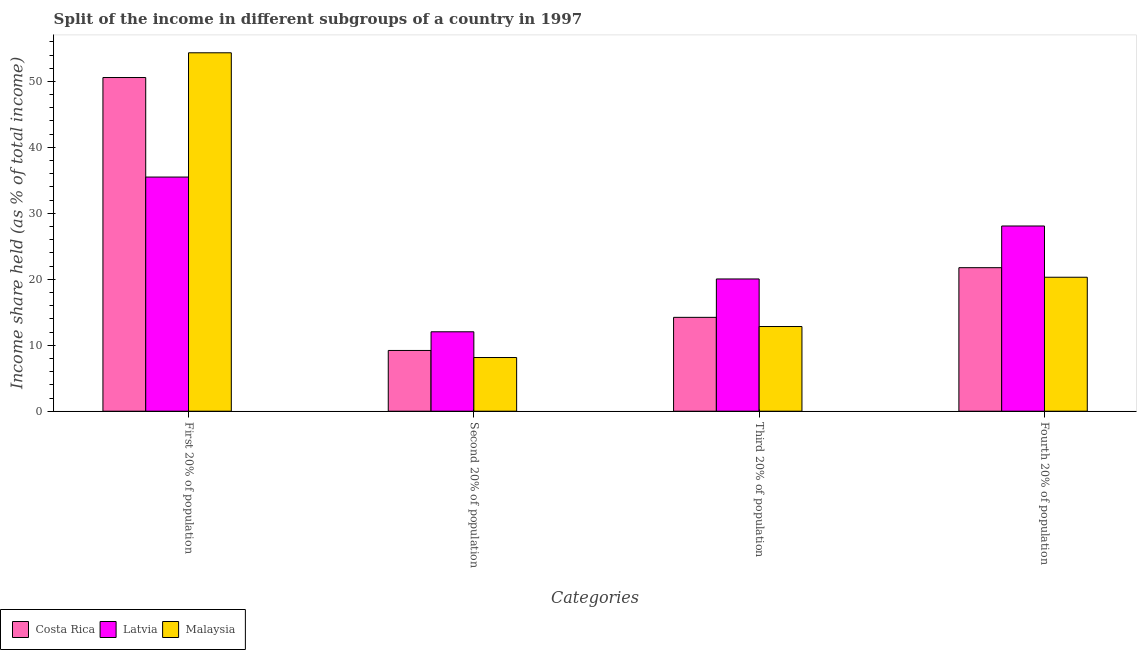How many groups of bars are there?
Make the answer very short. 4. Are the number of bars per tick equal to the number of legend labels?
Your answer should be compact. Yes. Are the number of bars on each tick of the X-axis equal?
Make the answer very short. Yes. How many bars are there on the 3rd tick from the left?
Provide a succinct answer. 3. What is the label of the 1st group of bars from the left?
Provide a short and direct response. First 20% of population. What is the share of the income held by fourth 20% of the population in Malaysia?
Give a very brief answer. 20.31. Across all countries, what is the maximum share of the income held by fourth 20% of the population?
Your response must be concise. 28.08. Across all countries, what is the minimum share of the income held by fourth 20% of the population?
Ensure brevity in your answer.  20.31. In which country was the share of the income held by third 20% of the population maximum?
Give a very brief answer. Latvia. In which country was the share of the income held by first 20% of the population minimum?
Provide a short and direct response. Latvia. What is the total share of the income held by third 20% of the population in the graph?
Give a very brief answer. 47.12. What is the difference between the share of the income held by third 20% of the population in Latvia and that in Malaysia?
Offer a terse response. 7.21. What is the difference between the share of the income held by second 20% of the population in Malaysia and the share of the income held by first 20% of the population in Latvia?
Make the answer very short. -27.36. What is the average share of the income held by first 20% of the population per country?
Give a very brief answer. 46.81. What is the difference between the share of the income held by second 20% of the population and share of the income held by first 20% of the population in Malaysia?
Offer a very short reply. -46.2. What is the ratio of the share of the income held by third 20% of the population in Costa Rica to that in Latvia?
Make the answer very short. 0.71. What is the difference between the highest and the second highest share of the income held by second 20% of the population?
Make the answer very short. 2.83. What is the difference between the highest and the lowest share of the income held by fourth 20% of the population?
Your answer should be very brief. 7.77. In how many countries, is the share of the income held by third 20% of the population greater than the average share of the income held by third 20% of the population taken over all countries?
Provide a succinct answer. 1. Is it the case that in every country, the sum of the share of the income held by fourth 20% of the population and share of the income held by third 20% of the population is greater than the sum of share of the income held by second 20% of the population and share of the income held by first 20% of the population?
Your answer should be very brief. No. What does the 3rd bar from the left in Fourth 20% of population represents?
Provide a short and direct response. Malaysia. What does the 3rd bar from the right in Fourth 20% of population represents?
Your answer should be very brief. Costa Rica. Is it the case that in every country, the sum of the share of the income held by first 20% of the population and share of the income held by second 20% of the population is greater than the share of the income held by third 20% of the population?
Ensure brevity in your answer.  Yes. How many countries are there in the graph?
Make the answer very short. 3. Does the graph contain any zero values?
Your answer should be very brief. No. Does the graph contain grids?
Keep it short and to the point. No. How are the legend labels stacked?
Give a very brief answer. Horizontal. What is the title of the graph?
Provide a short and direct response. Split of the income in different subgroups of a country in 1997. Does "Gabon" appear as one of the legend labels in the graph?
Offer a very short reply. No. What is the label or title of the X-axis?
Your response must be concise. Categories. What is the label or title of the Y-axis?
Keep it short and to the point. Income share held (as % of total income). What is the Income share held (as % of total income) of Costa Rica in First 20% of population?
Provide a succinct answer. 50.59. What is the Income share held (as % of total income) of Latvia in First 20% of population?
Your response must be concise. 35.5. What is the Income share held (as % of total income) in Malaysia in First 20% of population?
Provide a short and direct response. 54.34. What is the Income share held (as % of total income) of Costa Rica in Second 20% of population?
Your response must be concise. 9.21. What is the Income share held (as % of total income) of Latvia in Second 20% of population?
Your answer should be very brief. 12.04. What is the Income share held (as % of total income) in Malaysia in Second 20% of population?
Your response must be concise. 8.14. What is the Income share held (as % of total income) of Costa Rica in Third 20% of population?
Your answer should be compact. 14.23. What is the Income share held (as % of total income) of Latvia in Third 20% of population?
Make the answer very short. 20.05. What is the Income share held (as % of total income) of Malaysia in Third 20% of population?
Ensure brevity in your answer.  12.84. What is the Income share held (as % of total income) in Costa Rica in Fourth 20% of population?
Your response must be concise. 21.76. What is the Income share held (as % of total income) of Latvia in Fourth 20% of population?
Your response must be concise. 28.08. What is the Income share held (as % of total income) of Malaysia in Fourth 20% of population?
Your answer should be compact. 20.31. Across all Categories, what is the maximum Income share held (as % of total income) of Costa Rica?
Offer a very short reply. 50.59. Across all Categories, what is the maximum Income share held (as % of total income) of Latvia?
Provide a short and direct response. 35.5. Across all Categories, what is the maximum Income share held (as % of total income) of Malaysia?
Your response must be concise. 54.34. Across all Categories, what is the minimum Income share held (as % of total income) in Costa Rica?
Provide a short and direct response. 9.21. Across all Categories, what is the minimum Income share held (as % of total income) in Latvia?
Ensure brevity in your answer.  12.04. Across all Categories, what is the minimum Income share held (as % of total income) in Malaysia?
Provide a short and direct response. 8.14. What is the total Income share held (as % of total income) in Costa Rica in the graph?
Your answer should be very brief. 95.79. What is the total Income share held (as % of total income) in Latvia in the graph?
Ensure brevity in your answer.  95.67. What is the total Income share held (as % of total income) in Malaysia in the graph?
Make the answer very short. 95.63. What is the difference between the Income share held (as % of total income) in Costa Rica in First 20% of population and that in Second 20% of population?
Ensure brevity in your answer.  41.38. What is the difference between the Income share held (as % of total income) in Latvia in First 20% of population and that in Second 20% of population?
Your response must be concise. 23.46. What is the difference between the Income share held (as % of total income) in Malaysia in First 20% of population and that in Second 20% of population?
Your response must be concise. 46.2. What is the difference between the Income share held (as % of total income) in Costa Rica in First 20% of population and that in Third 20% of population?
Make the answer very short. 36.36. What is the difference between the Income share held (as % of total income) of Latvia in First 20% of population and that in Third 20% of population?
Your answer should be very brief. 15.45. What is the difference between the Income share held (as % of total income) in Malaysia in First 20% of population and that in Third 20% of population?
Your answer should be very brief. 41.5. What is the difference between the Income share held (as % of total income) of Costa Rica in First 20% of population and that in Fourth 20% of population?
Offer a very short reply. 28.83. What is the difference between the Income share held (as % of total income) of Latvia in First 20% of population and that in Fourth 20% of population?
Make the answer very short. 7.42. What is the difference between the Income share held (as % of total income) of Malaysia in First 20% of population and that in Fourth 20% of population?
Offer a terse response. 34.03. What is the difference between the Income share held (as % of total income) of Costa Rica in Second 20% of population and that in Third 20% of population?
Make the answer very short. -5.02. What is the difference between the Income share held (as % of total income) of Latvia in Second 20% of population and that in Third 20% of population?
Offer a terse response. -8.01. What is the difference between the Income share held (as % of total income) in Costa Rica in Second 20% of population and that in Fourth 20% of population?
Make the answer very short. -12.55. What is the difference between the Income share held (as % of total income) in Latvia in Second 20% of population and that in Fourth 20% of population?
Provide a short and direct response. -16.04. What is the difference between the Income share held (as % of total income) in Malaysia in Second 20% of population and that in Fourth 20% of population?
Your answer should be compact. -12.17. What is the difference between the Income share held (as % of total income) of Costa Rica in Third 20% of population and that in Fourth 20% of population?
Ensure brevity in your answer.  -7.53. What is the difference between the Income share held (as % of total income) in Latvia in Third 20% of population and that in Fourth 20% of population?
Provide a short and direct response. -8.03. What is the difference between the Income share held (as % of total income) of Malaysia in Third 20% of population and that in Fourth 20% of population?
Make the answer very short. -7.47. What is the difference between the Income share held (as % of total income) in Costa Rica in First 20% of population and the Income share held (as % of total income) in Latvia in Second 20% of population?
Your answer should be very brief. 38.55. What is the difference between the Income share held (as % of total income) in Costa Rica in First 20% of population and the Income share held (as % of total income) in Malaysia in Second 20% of population?
Keep it short and to the point. 42.45. What is the difference between the Income share held (as % of total income) of Latvia in First 20% of population and the Income share held (as % of total income) of Malaysia in Second 20% of population?
Your answer should be very brief. 27.36. What is the difference between the Income share held (as % of total income) in Costa Rica in First 20% of population and the Income share held (as % of total income) in Latvia in Third 20% of population?
Your answer should be very brief. 30.54. What is the difference between the Income share held (as % of total income) in Costa Rica in First 20% of population and the Income share held (as % of total income) in Malaysia in Third 20% of population?
Keep it short and to the point. 37.75. What is the difference between the Income share held (as % of total income) in Latvia in First 20% of population and the Income share held (as % of total income) in Malaysia in Third 20% of population?
Your answer should be very brief. 22.66. What is the difference between the Income share held (as % of total income) in Costa Rica in First 20% of population and the Income share held (as % of total income) in Latvia in Fourth 20% of population?
Make the answer very short. 22.51. What is the difference between the Income share held (as % of total income) of Costa Rica in First 20% of population and the Income share held (as % of total income) of Malaysia in Fourth 20% of population?
Your answer should be very brief. 30.28. What is the difference between the Income share held (as % of total income) of Latvia in First 20% of population and the Income share held (as % of total income) of Malaysia in Fourth 20% of population?
Provide a succinct answer. 15.19. What is the difference between the Income share held (as % of total income) of Costa Rica in Second 20% of population and the Income share held (as % of total income) of Latvia in Third 20% of population?
Your response must be concise. -10.84. What is the difference between the Income share held (as % of total income) of Costa Rica in Second 20% of population and the Income share held (as % of total income) of Malaysia in Third 20% of population?
Provide a short and direct response. -3.63. What is the difference between the Income share held (as % of total income) in Costa Rica in Second 20% of population and the Income share held (as % of total income) in Latvia in Fourth 20% of population?
Your response must be concise. -18.87. What is the difference between the Income share held (as % of total income) in Latvia in Second 20% of population and the Income share held (as % of total income) in Malaysia in Fourth 20% of population?
Offer a terse response. -8.27. What is the difference between the Income share held (as % of total income) in Costa Rica in Third 20% of population and the Income share held (as % of total income) in Latvia in Fourth 20% of population?
Provide a short and direct response. -13.85. What is the difference between the Income share held (as % of total income) of Costa Rica in Third 20% of population and the Income share held (as % of total income) of Malaysia in Fourth 20% of population?
Provide a succinct answer. -6.08. What is the difference between the Income share held (as % of total income) of Latvia in Third 20% of population and the Income share held (as % of total income) of Malaysia in Fourth 20% of population?
Your response must be concise. -0.26. What is the average Income share held (as % of total income) in Costa Rica per Categories?
Your response must be concise. 23.95. What is the average Income share held (as % of total income) in Latvia per Categories?
Provide a short and direct response. 23.92. What is the average Income share held (as % of total income) in Malaysia per Categories?
Provide a short and direct response. 23.91. What is the difference between the Income share held (as % of total income) of Costa Rica and Income share held (as % of total income) of Latvia in First 20% of population?
Your response must be concise. 15.09. What is the difference between the Income share held (as % of total income) in Costa Rica and Income share held (as % of total income) in Malaysia in First 20% of population?
Your answer should be compact. -3.75. What is the difference between the Income share held (as % of total income) of Latvia and Income share held (as % of total income) of Malaysia in First 20% of population?
Your response must be concise. -18.84. What is the difference between the Income share held (as % of total income) of Costa Rica and Income share held (as % of total income) of Latvia in Second 20% of population?
Provide a short and direct response. -2.83. What is the difference between the Income share held (as % of total income) of Costa Rica and Income share held (as % of total income) of Malaysia in Second 20% of population?
Keep it short and to the point. 1.07. What is the difference between the Income share held (as % of total income) in Latvia and Income share held (as % of total income) in Malaysia in Second 20% of population?
Offer a terse response. 3.9. What is the difference between the Income share held (as % of total income) in Costa Rica and Income share held (as % of total income) in Latvia in Third 20% of population?
Offer a terse response. -5.82. What is the difference between the Income share held (as % of total income) of Costa Rica and Income share held (as % of total income) of Malaysia in Third 20% of population?
Provide a short and direct response. 1.39. What is the difference between the Income share held (as % of total income) of Latvia and Income share held (as % of total income) of Malaysia in Third 20% of population?
Your response must be concise. 7.21. What is the difference between the Income share held (as % of total income) of Costa Rica and Income share held (as % of total income) of Latvia in Fourth 20% of population?
Offer a terse response. -6.32. What is the difference between the Income share held (as % of total income) in Costa Rica and Income share held (as % of total income) in Malaysia in Fourth 20% of population?
Offer a terse response. 1.45. What is the difference between the Income share held (as % of total income) of Latvia and Income share held (as % of total income) of Malaysia in Fourth 20% of population?
Give a very brief answer. 7.77. What is the ratio of the Income share held (as % of total income) of Costa Rica in First 20% of population to that in Second 20% of population?
Your response must be concise. 5.49. What is the ratio of the Income share held (as % of total income) of Latvia in First 20% of population to that in Second 20% of population?
Your answer should be very brief. 2.95. What is the ratio of the Income share held (as % of total income) in Malaysia in First 20% of population to that in Second 20% of population?
Offer a very short reply. 6.68. What is the ratio of the Income share held (as % of total income) in Costa Rica in First 20% of population to that in Third 20% of population?
Give a very brief answer. 3.56. What is the ratio of the Income share held (as % of total income) of Latvia in First 20% of population to that in Third 20% of population?
Make the answer very short. 1.77. What is the ratio of the Income share held (as % of total income) of Malaysia in First 20% of population to that in Third 20% of population?
Your answer should be very brief. 4.23. What is the ratio of the Income share held (as % of total income) of Costa Rica in First 20% of population to that in Fourth 20% of population?
Your answer should be compact. 2.32. What is the ratio of the Income share held (as % of total income) of Latvia in First 20% of population to that in Fourth 20% of population?
Keep it short and to the point. 1.26. What is the ratio of the Income share held (as % of total income) in Malaysia in First 20% of population to that in Fourth 20% of population?
Your answer should be compact. 2.68. What is the ratio of the Income share held (as % of total income) in Costa Rica in Second 20% of population to that in Third 20% of population?
Offer a terse response. 0.65. What is the ratio of the Income share held (as % of total income) of Latvia in Second 20% of population to that in Third 20% of population?
Make the answer very short. 0.6. What is the ratio of the Income share held (as % of total income) of Malaysia in Second 20% of population to that in Third 20% of population?
Provide a succinct answer. 0.63. What is the ratio of the Income share held (as % of total income) in Costa Rica in Second 20% of population to that in Fourth 20% of population?
Your answer should be compact. 0.42. What is the ratio of the Income share held (as % of total income) in Latvia in Second 20% of population to that in Fourth 20% of population?
Offer a terse response. 0.43. What is the ratio of the Income share held (as % of total income) of Malaysia in Second 20% of population to that in Fourth 20% of population?
Give a very brief answer. 0.4. What is the ratio of the Income share held (as % of total income) of Costa Rica in Third 20% of population to that in Fourth 20% of population?
Keep it short and to the point. 0.65. What is the ratio of the Income share held (as % of total income) of Latvia in Third 20% of population to that in Fourth 20% of population?
Your response must be concise. 0.71. What is the ratio of the Income share held (as % of total income) in Malaysia in Third 20% of population to that in Fourth 20% of population?
Keep it short and to the point. 0.63. What is the difference between the highest and the second highest Income share held (as % of total income) in Costa Rica?
Your answer should be compact. 28.83. What is the difference between the highest and the second highest Income share held (as % of total income) in Latvia?
Offer a very short reply. 7.42. What is the difference between the highest and the second highest Income share held (as % of total income) of Malaysia?
Offer a terse response. 34.03. What is the difference between the highest and the lowest Income share held (as % of total income) in Costa Rica?
Offer a very short reply. 41.38. What is the difference between the highest and the lowest Income share held (as % of total income) in Latvia?
Provide a short and direct response. 23.46. What is the difference between the highest and the lowest Income share held (as % of total income) in Malaysia?
Give a very brief answer. 46.2. 